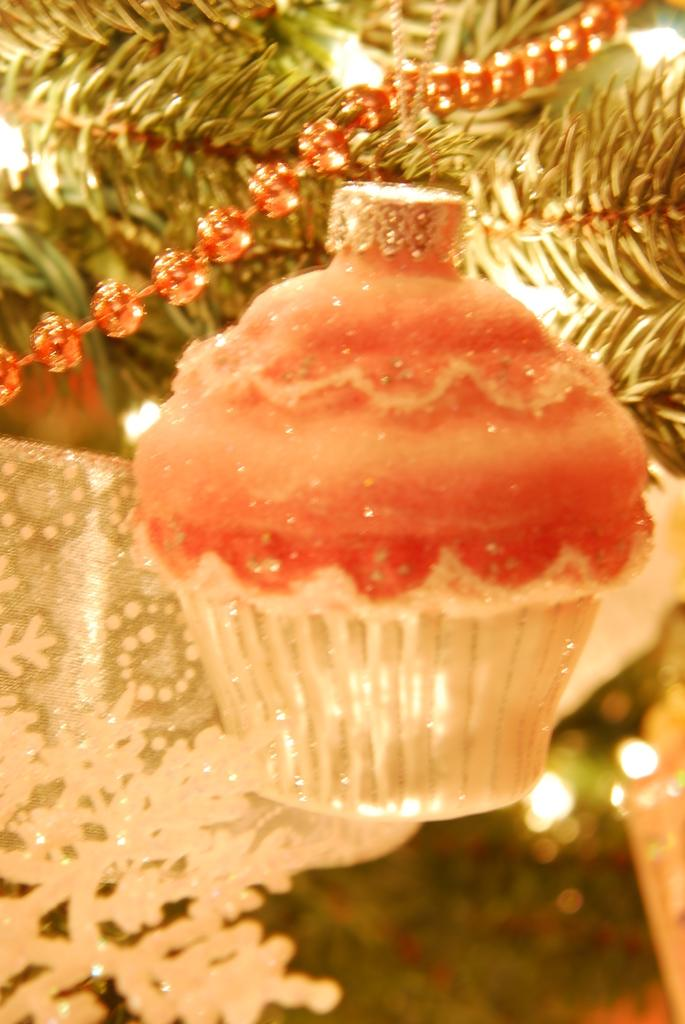What is the main subject of the image? There is a Christmas tree in the image. What is the color of the Christmas tree? The Christmas tree is green in color. Are there any additional items on the tree? Yes, there are decorative items attached to the tree. What colors are the decorative items? The decorative items are orange and white in color. What else can be seen on the Christmas tree? There are lights on the tree. How much glue is needed to attach the decorative items to the tree? There is no information about glue in the image, so it cannot be determined how much glue is needed. What is the fifth decorative item on the tree? The facts provided do not mention a specific number of decorative items, so it is impossible to determine the fifth item. 